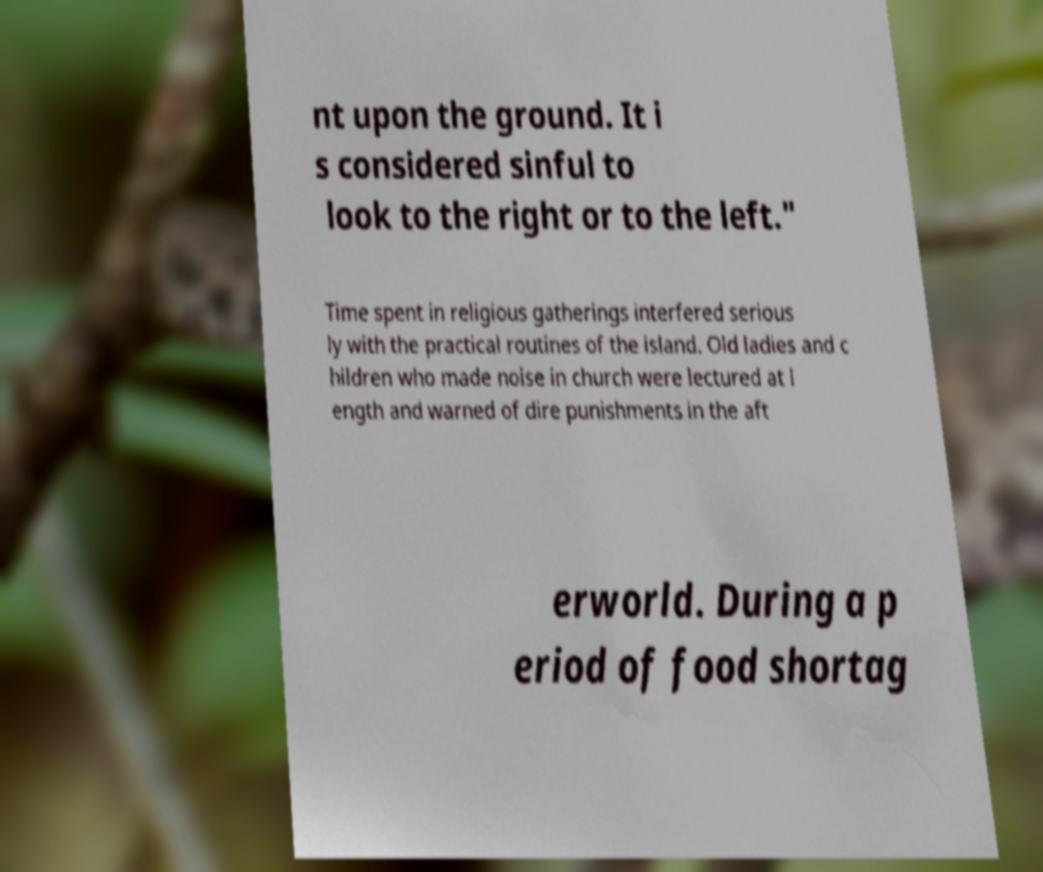There's text embedded in this image that I need extracted. Can you transcribe it verbatim? nt upon the ground. It i s considered sinful to look to the right or to the left." Time spent in religious gatherings interfered serious ly with the practical routines of the island. Old ladies and c hildren who made noise in church were lectured at l ength and warned of dire punishments in the aft erworld. During a p eriod of food shortag 